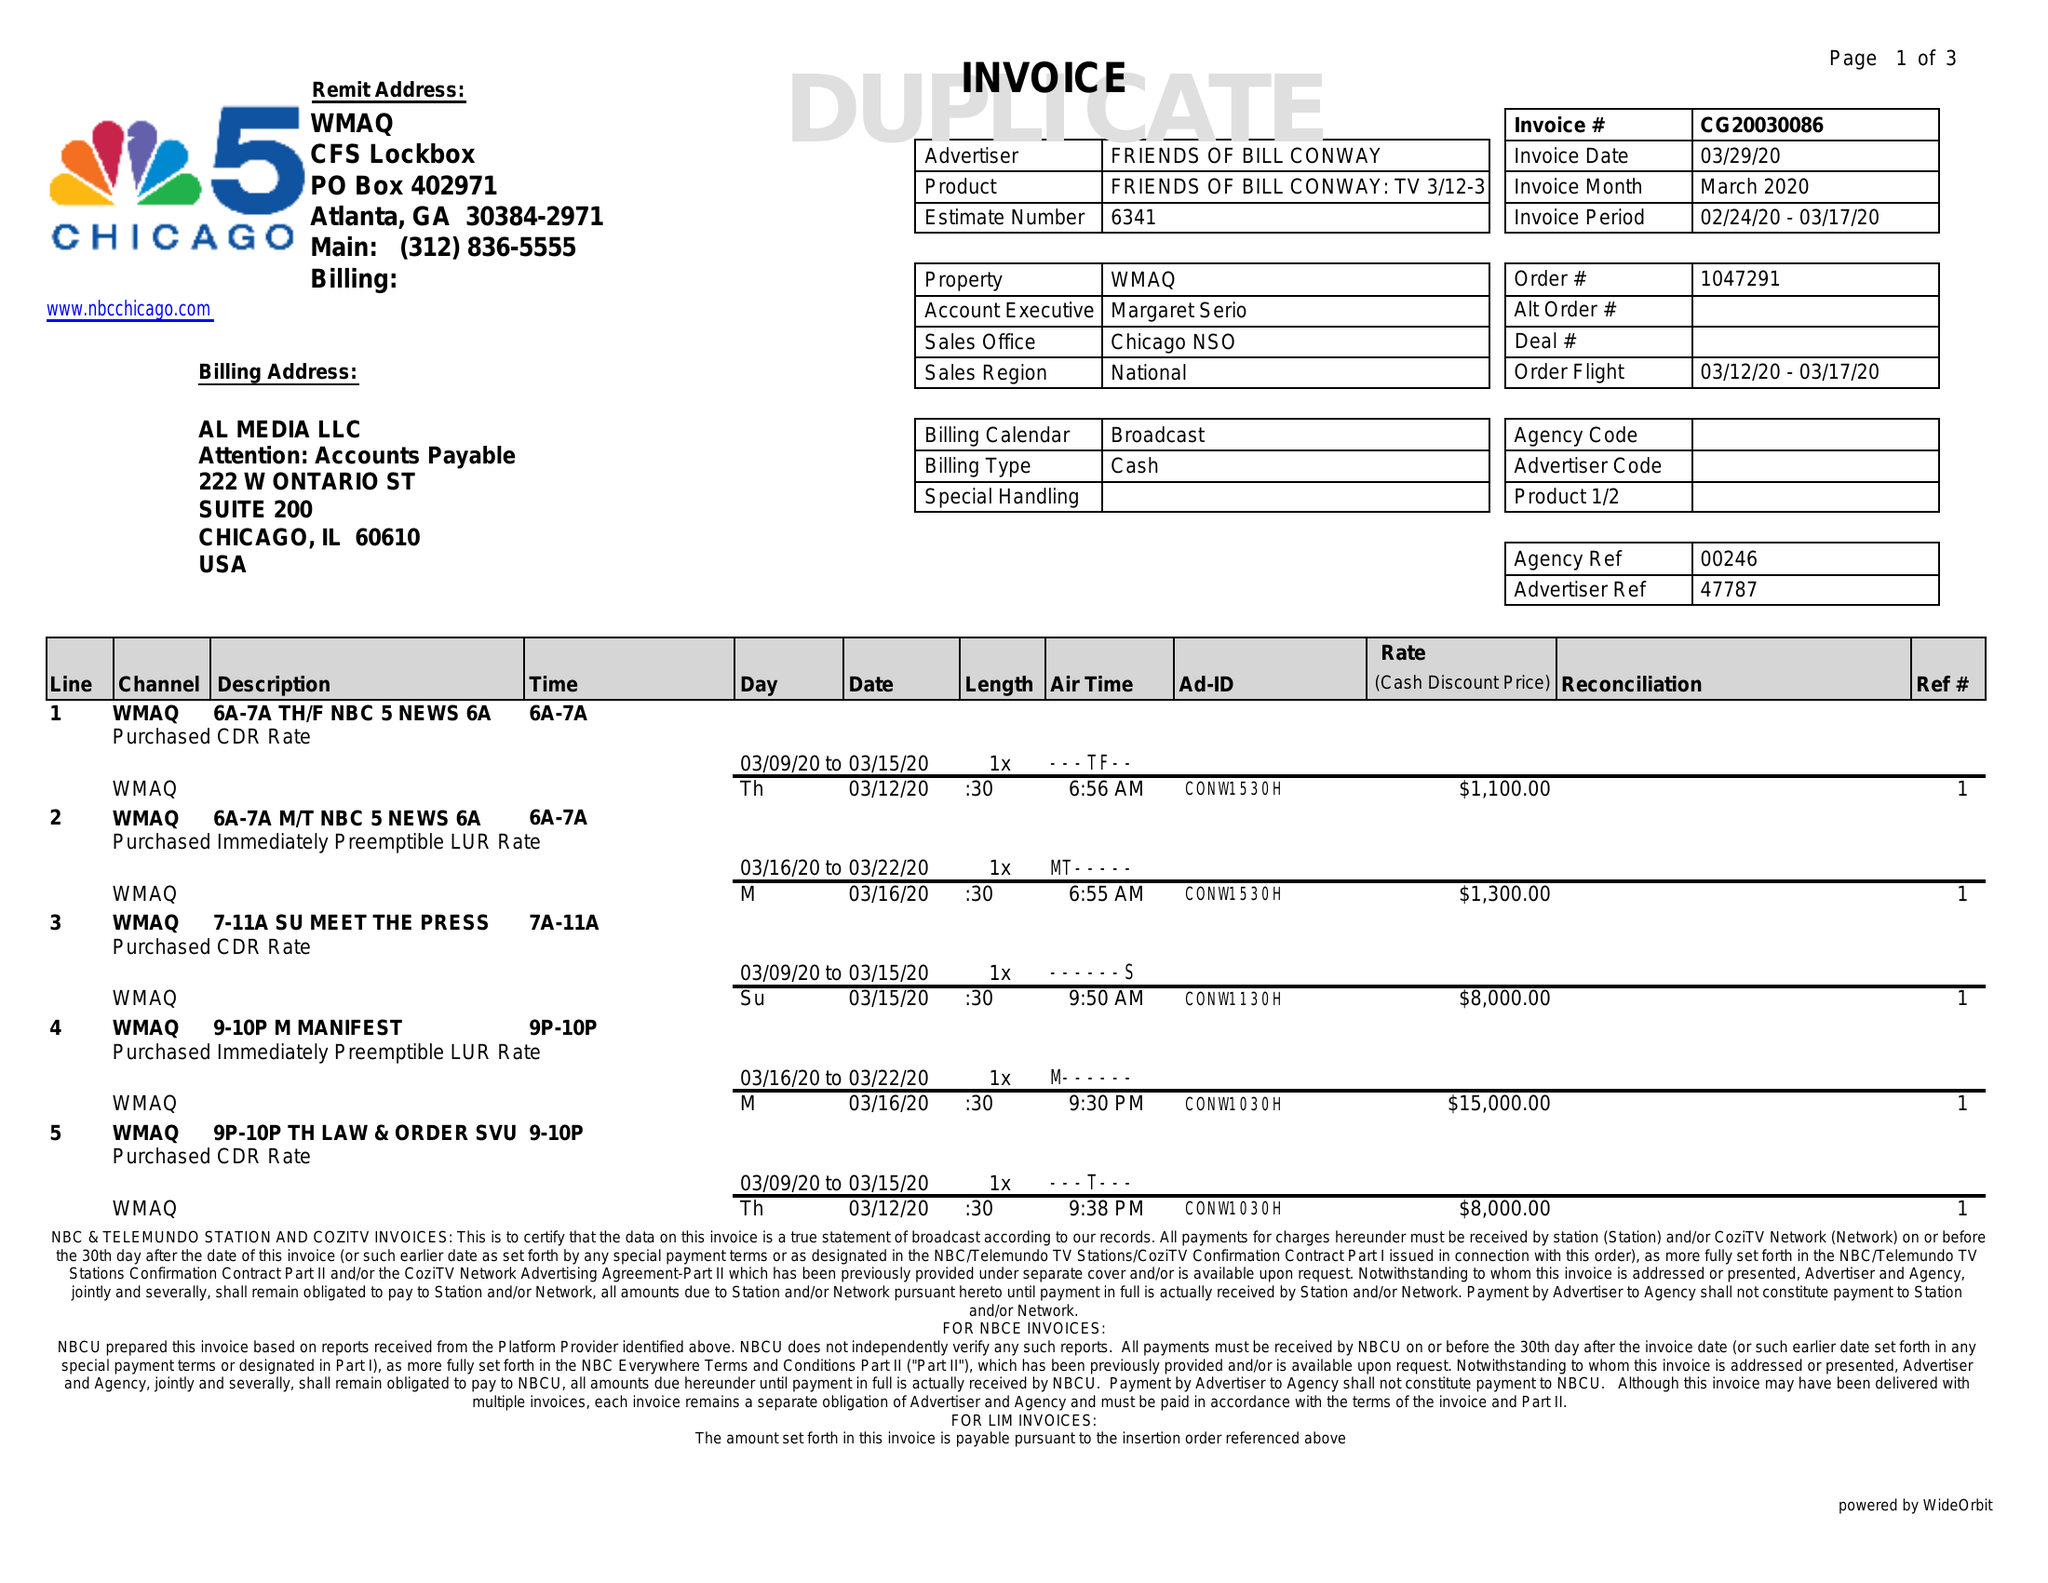What is the value for the flight_to?
Answer the question using a single word or phrase. 03/17/20 